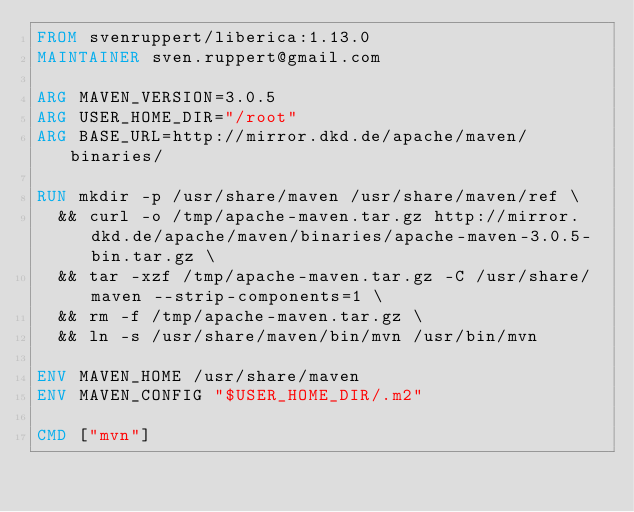Convert code to text. <code><loc_0><loc_0><loc_500><loc_500><_Dockerfile_>FROM svenruppert/liberica:1.13.0
MAINTAINER sven.ruppert@gmail.com

ARG MAVEN_VERSION=3.0.5
ARG USER_HOME_DIR="/root"
ARG BASE_URL=http://mirror.dkd.de/apache/maven/binaries/

RUN mkdir -p /usr/share/maven /usr/share/maven/ref \
  && curl -o /tmp/apache-maven.tar.gz http://mirror.dkd.de/apache/maven/binaries/apache-maven-3.0.5-bin.tar.gz \
  && tar -xzf /tmp/apache-maven.tar.gz -C /usr/share/maven --strip-components=1 \
  && rm -f /tmp/apache-maven.tar.gz \
  && ln -s /usr/share/maven/bin/mvn /usr/bin/mvn

ENV MAVEN_HOME /usr/share/maven
ENV MAVEN_CONFIG "$USER_HOME_DIR/.m2"

CMD ["mvn"]</code> 